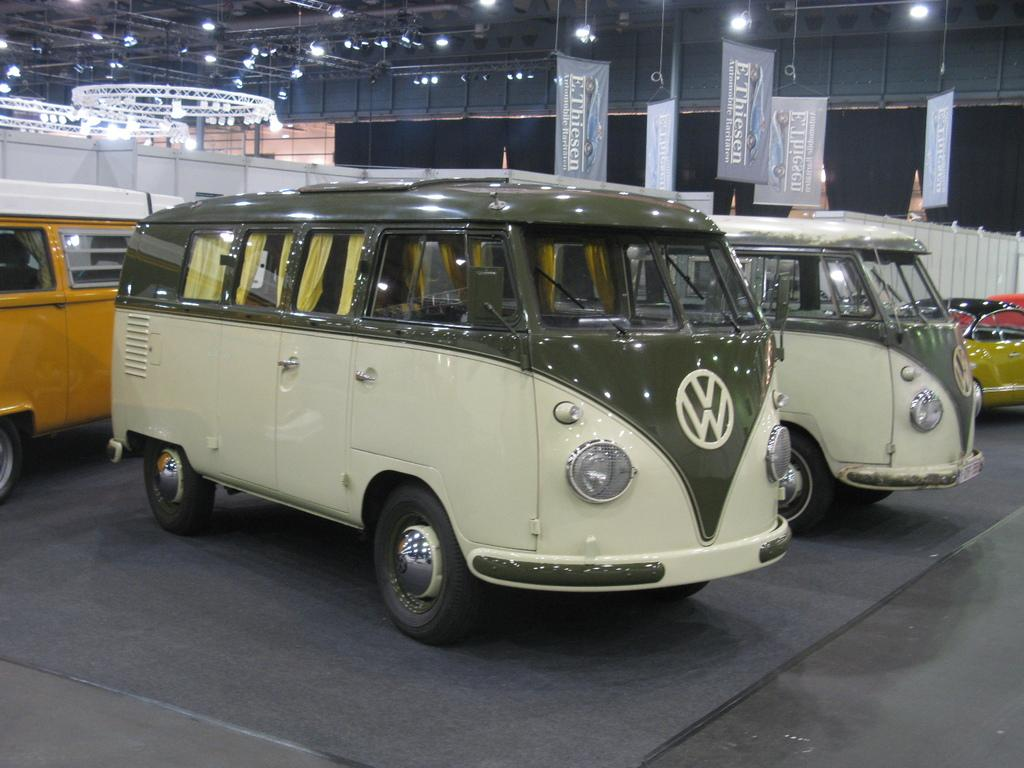What is located in the center of the image? There are vehicles on the ground in the center of the image. Can you describe the vehicles in the background? There are vehicles visible in the background. What is in the background besides the vehicles? There is a wall and advertisements in the background, as well as lights. What type of berry is being advertised on the front of the car in the image? There is no berry being advertised on the front of a car in the image. How many cars are present in the image? The number of cars cannot be definitively determined from the provided facts, as only the presence of vehicles is mentioned. 